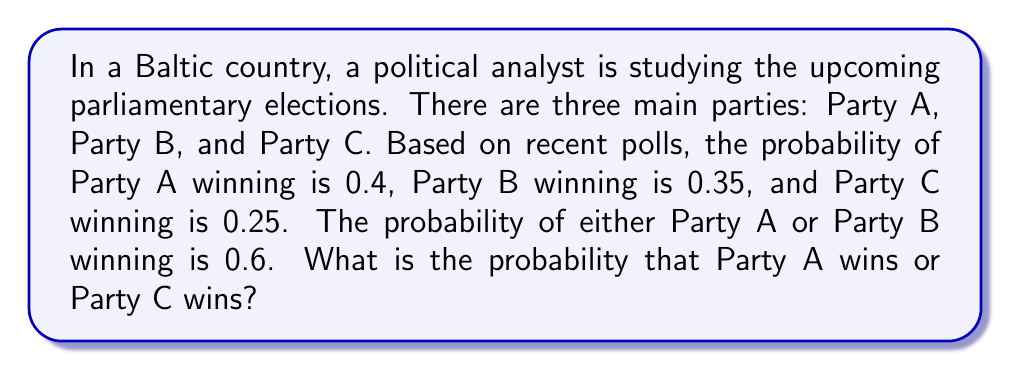Teach me how to tackle this problem. To solve this problem, we'll use basic set theory and probability concepts:

1) Let's define our sets:
   A = event that Party A wins
   B = event that Party B wins
   C = event that Party C wins

2) Given probabilities:
   $P(A) = 0.4$
   $P(B) = 0.35$
   $P(C) = 0.25$
   $P(A \cup B) = 0.6$

3) We need to find $P(A \cup C)$

4) We can use the addition rule of probability:
   $P(A \cup C) = P(A) + P(C) - P(A \cap C)$

5) We know $P(A)$ and $P(C)$, but we need to find $P(A \cap C)$

6) We can use the given information about $P(A \cup B)$ to find this:
   $P(A \cup B) = P(A) + P(B) - P(A \cap B)$
   $0.6 = 0.4 + 0.35 - P(A \cap B)$
   $P(A \cap B) = 0.15$

7) Since the events are mutually exclusive (only one party can win), we know that:
   $P(A \cap B) = P(A \cap C) = P(B \cap C) = 0$

8) Now we can solve our original equation:
   $P(A \cup C) = P(A) + P(C) - P(A \cap C)$
   $P(A \cup C) = 0.4 + 0.25 - 0$
   $P(A \cup C) = 0.65$

Therefore, the probability that either Party A wins or Party C wins is 0.65 or 65%.
Answer: $P(A \cup C) = 0.65$ or $65\%$ 